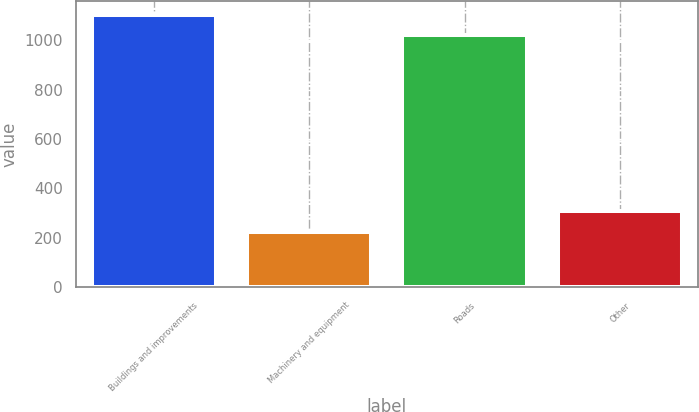Convert chart. <chart><loc_0><loc_0><loc_500><loc_500><bar_chart><fcel>Buildings and improvements<fcel>Machinery and equipment<fcel>Roads<fcel>Other<nl><fcel>1101.5<fcel>225<fcel>1020<fcel>310<nl></chart> 